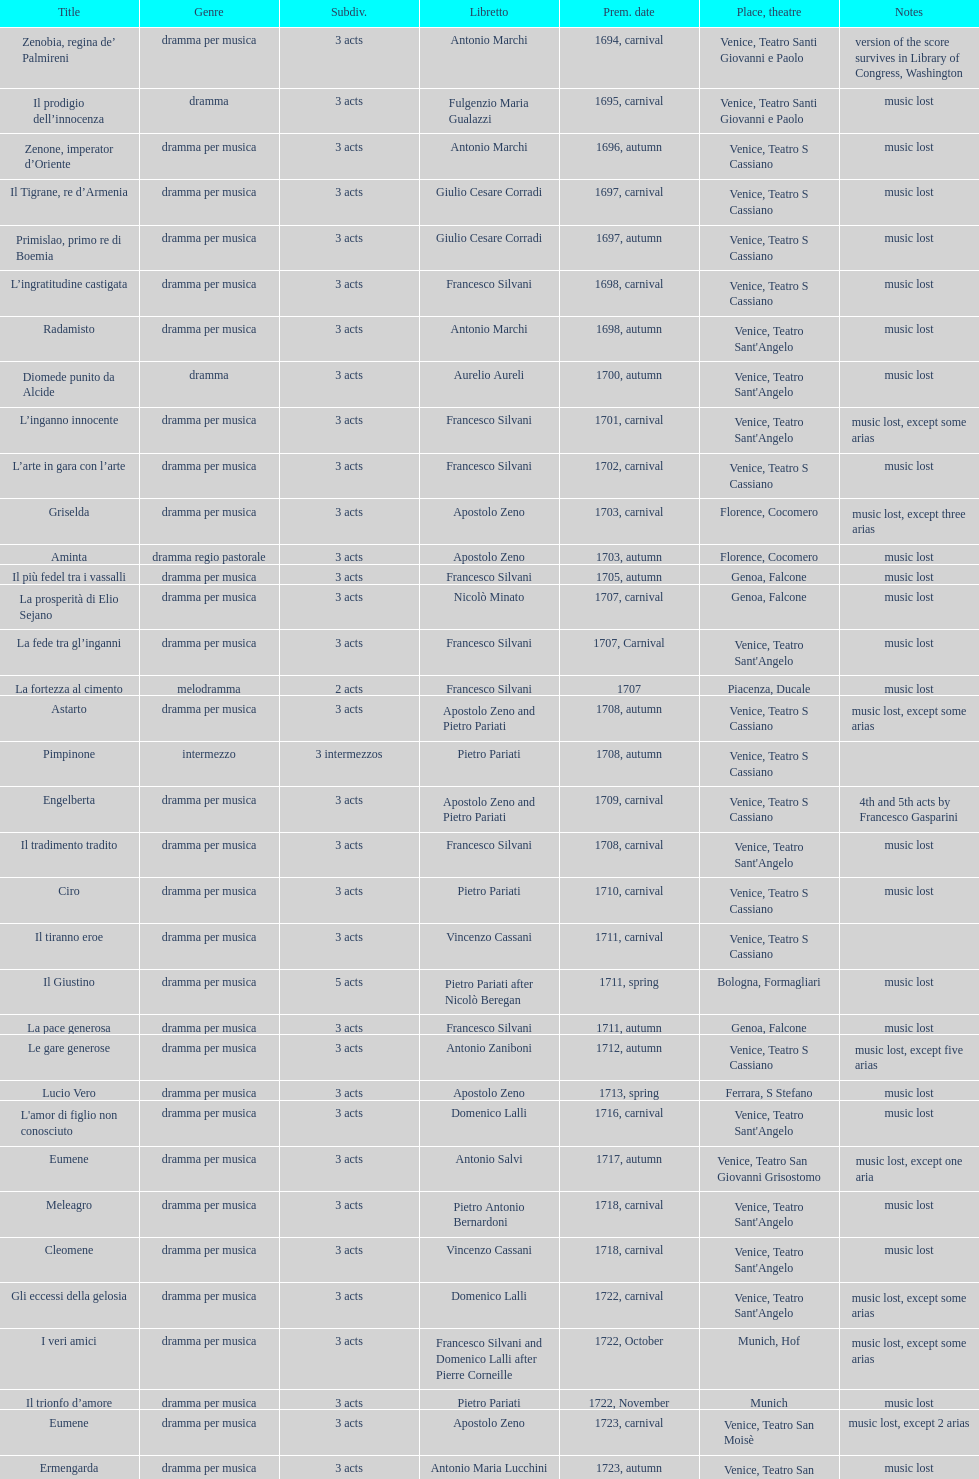How many operas on this list has at least 3 acts? 51. 